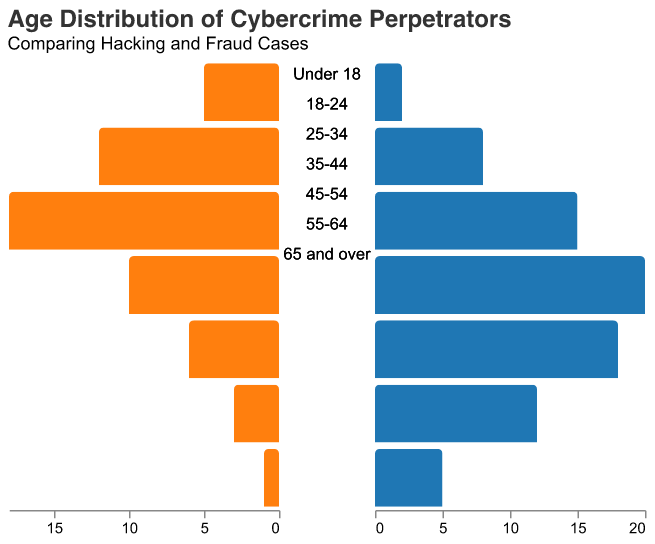Which age group has the highest number of hacking perpetrators? By looking at the left side of the pyramid (colored in blue), we can see that the age group 25-34 has the largest bar, indicating it has the highest number of hacking perpetrators.
Answer: 25-34 How many hacking perpetrators are in the 18-24 age group? Observing the left side of the pyramid, we see that the bar corresponding to the 18-24 age group reaches -12. This means there are 12 hacking perpetrators in this age group.
Answer: 12 What is the total number of fraud cases for people aged 45 and above? We need to sum the fraud cases for age groups 45-54, 55-64, and 65 and over. These values are 18, 12, and 5 respectively. Summing them up: 18 + 12 + 5 = 35.
Answer: 35 Which category has more perpetrators aged 35-44? By comparing the lengths of the bars for the 35-44 age group, we notice that the fraud bar (orange) is longer than the hacking bar (blue). Hence, the fraud category has more perpetrators.
Answer: Fraud Are there more hacking or fraud cases for people under 18? By comparing the bars for the "Under 18" age group, the hacking bar (blue) indicates -5 and the fraud bar (orange) indicates 2. Since -5 is greater in magnitude, there are more hacking cases for people under 18.
Answer: Hacking What is the ratio of hacking to fraud cases for the age group 55-64? The age group 55-64 has 3 hacking and 12 fraud cases.
Ratio = 3/12 = 1/4 = 0.25
Answer: 0.25 